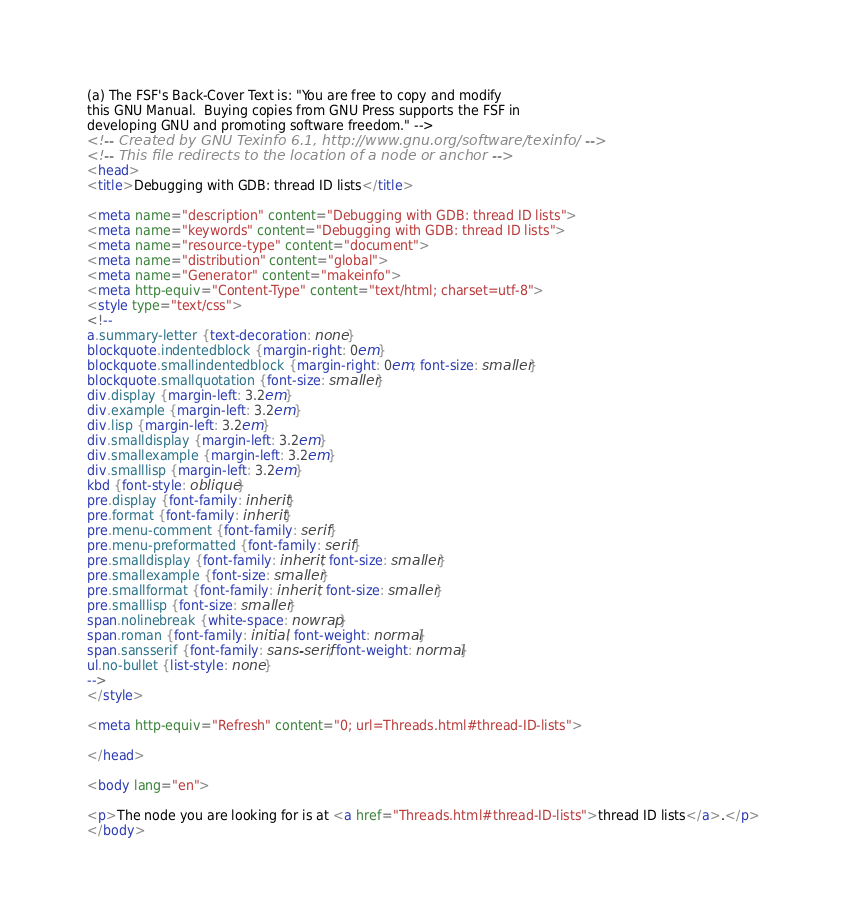Convert code to text. <code><loc_0><loc_0><loc_500><loc_500><_HTML_>
(a) The FSF's Back-Cover Text is: "You are free to copy and modify
this GNU Manual.  Buying copies from GNU Press supports the FSF in
developing GNU and promoting software freedom." -->
<!-- Created by GNU Texinfo 6.1, http://www.gnu.org/software/texinfo/ -->
<!-- This file redirects to the location of a node or anchor -->
<head>
<title>Debugging with GDB: thread ID lists</title>

<meta name="description" content="Debugging with GDB: thread ID lists">
<meta name="keywords" content="Debugging with GDB: thread ID lists">
<meta name="resource-type" content="document">
<meta name="distribution" content="global">
<meta name="Generator" content="makeinfo">
<meta http-equiv="Content-Type" content="text/html; charset=utf-8">
<style type="text/css">
<!--
a.summary-letter {text-decoration: none}
blockquote.indentedblock {margin-right: 0em}
blockquote.smallindentedblock {margin-right: 0em; font-size: smaller}
blockquote.smallquotation {font-size: smaller}
div.display {margin-left: 3.2em}
div.example {margin-left: 3.2em}
div.lisp {margin-left: 3.2em}
div.smalldisplay {margin-left: 3.2em}
div.smallexample {margin-left: 3.2em}
div.smalllisp {margin-left: 3.2em}
kbd {font-style: oblique}
pre.display {font-family: inherit}
pre.format {font-family: inherit}
pre.menu-comment {font-family: serif}
pre.menu-preformatted {font-family: serif}
pre.smalldisplay {font-family: inherit; font-size: smaller}
pre.smallexample {font-size: smaller}
pre.smallformat {font-family: inherit; font-size: smaller}
pre.smalllisp {font-size: smaller}
span.nolinebreak {white-space: nowrap}
span.roman {font-family: initial; font-weight: normal}
span.sansserif {font-family: sans-serif; font-weight: normal}
ul.no-bullet {list-style: none}
-->
</style>

<meta http-equiv="Refresh" content="0; url=Threads.html#thread-ID-lists">

</head>

<body lang="en">

<p>The node you are looking for is at <a href="Threads.html#thread-ID-lists">thread ID lists</a>.</p>
</body>
</code> 